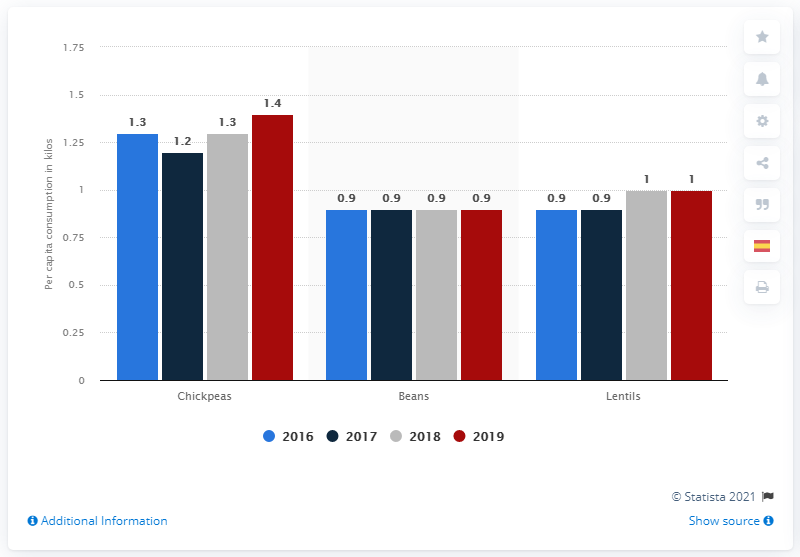Identify some key points in this picture. According to the study, chickpeas were the most consumed type of pulse in Spain during the study period. 